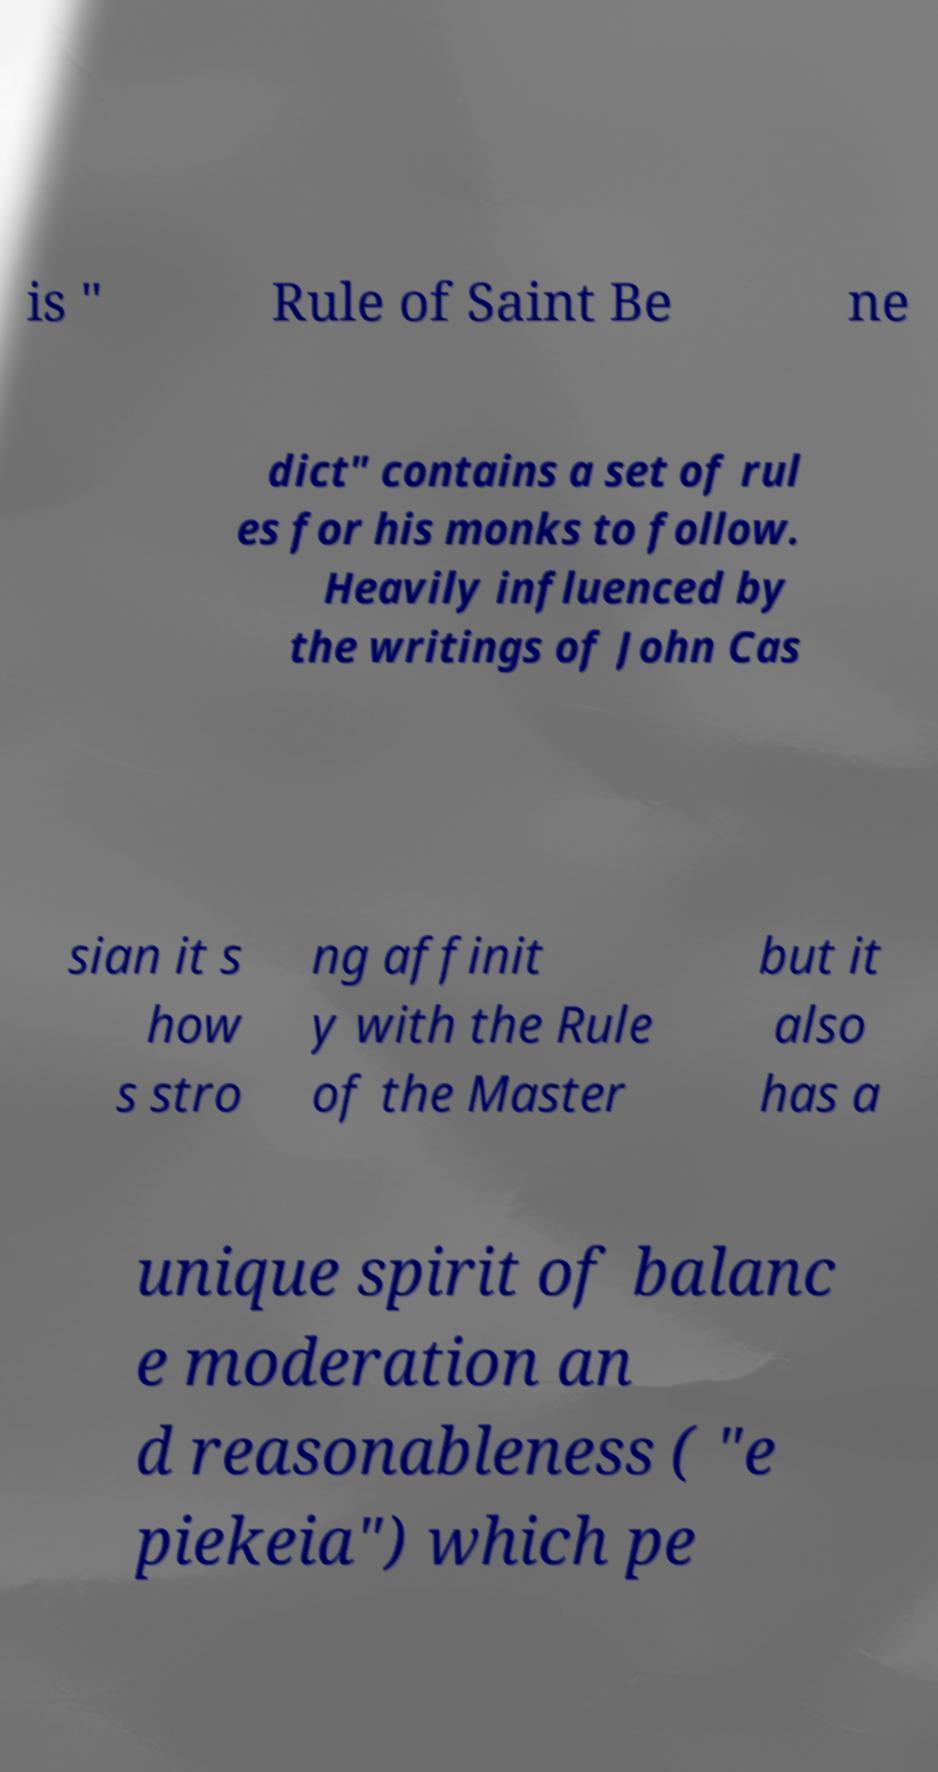Can you accurately transcribe the text from the provided image for me? is " Rule of Saint Be ne dict" contains a set of rul es for his monks to follow. Heavily influenced by the writings of John Cas sian it s how s stro ng affinit y with the Rule of the Master but it also has a unique spirit of balanc e moderation an d reasonableness ( "e piekeia") which pe 